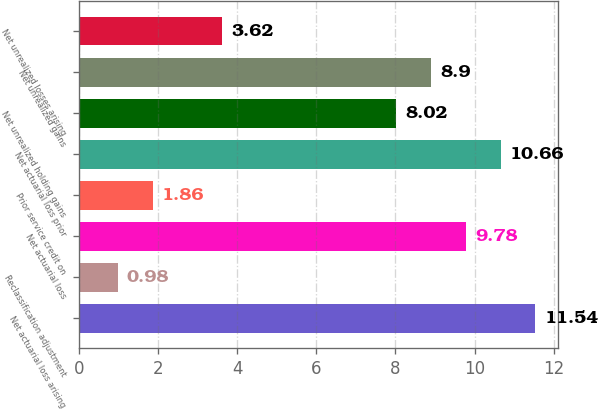<chart> <loc_0><loc_0><loc_500><loc_500><bar_chart><fcel>Net actuarial loss arising<fcel>Reclassification adjustment<fcel>Net actuarial loss<fcel>Prior service credit on<fcel>Net actuarial loss prior<fcel>Net unrealized holding gains<fcel>Net unrealized gains<fcel>Net unrealized losses arising<nl><fcel>11.54<fcel>0.98<fcel>9.78<fcel>1.86<fcel>10.66<fcel>8.02<fcel>8.9<fcel>3.62<nl></chart> 